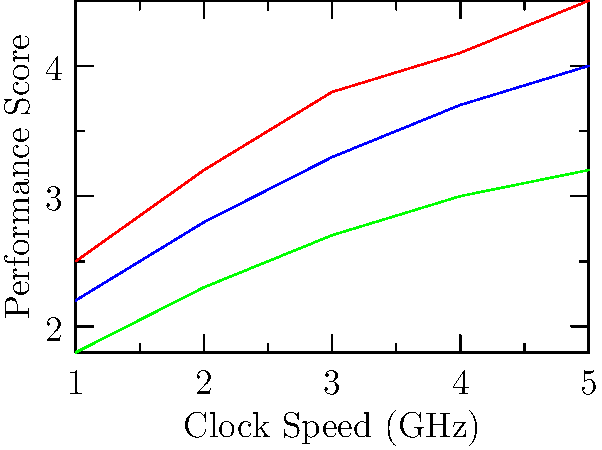As a computer science student and part-time streamer, you're analyzing CPU performance for potential upgrades. The graph shows performance scores for three CPU models (A, B, and C) across different clock speeds. At which clock speed does CPU B start outperforming CPU C by at least 0.5 points? To solve this question, we need to compare the performance scores of CPU B and CPU C at each clock speed:

1. At 1 GHz:
   CPU B: 2.2
   CPU C: 1.8
   Difference: 2.2 - 1.8 = 0.4

2. At 2 GHz:
   CPU B: 2.8
   CPU C: 2.3
   Difference: 2.8 - 2.3 = 0.5

3. At 3 GHz:
   CPU B: 3.3
   CPU C: 2.7
   Difference: 3.3 - 2.7 = 0.6

4. At 4 GHz:
   CPU B: 3.7
   CPU C: 3.0
   Difference: 3.7 - 3.0 = 0.7

5. At 5 GHz:
   CPU B: 4.0
   CPU C: 3.2
   Difference: 4.0 - 3.2 = 0.8

The first clock speed at which the difference in performance scores between CPU B and CPU C is at least 0.5 points is 2 GHz.
Answer: 2 GHz 